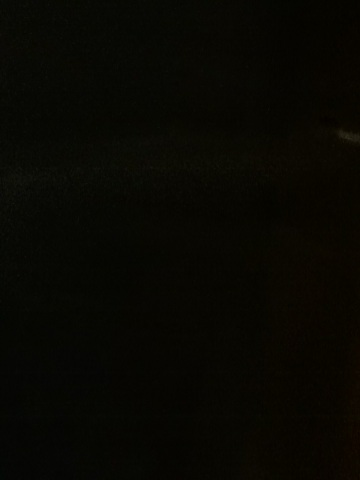Is there any recognizable feature or object in this image? The image is too dark to make out any recognizable features or objects. To provide more details, a version of the image with adjusted brightness or one taken under better lighting conditions would be necessary. 